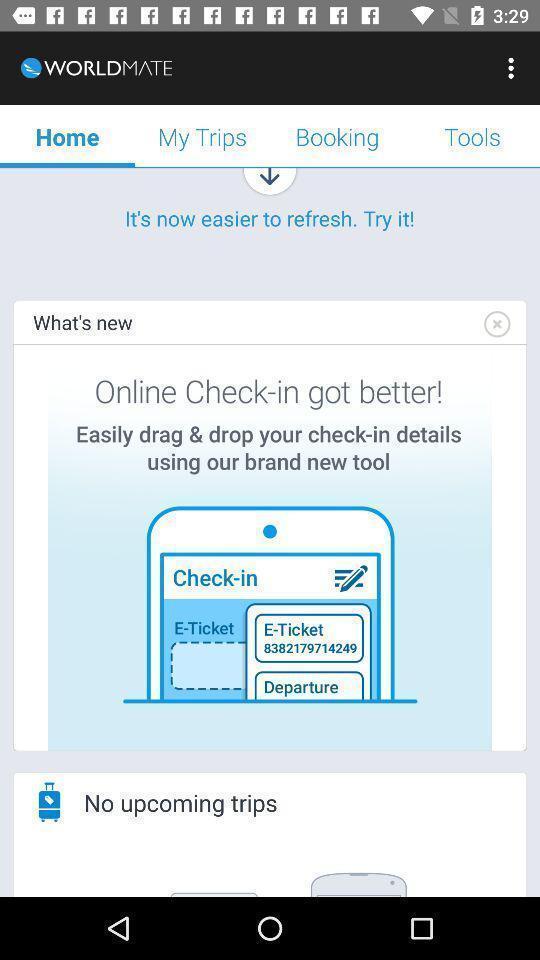Explain what's happening in this screen capture. Screen shows multiple options in a travel application. 